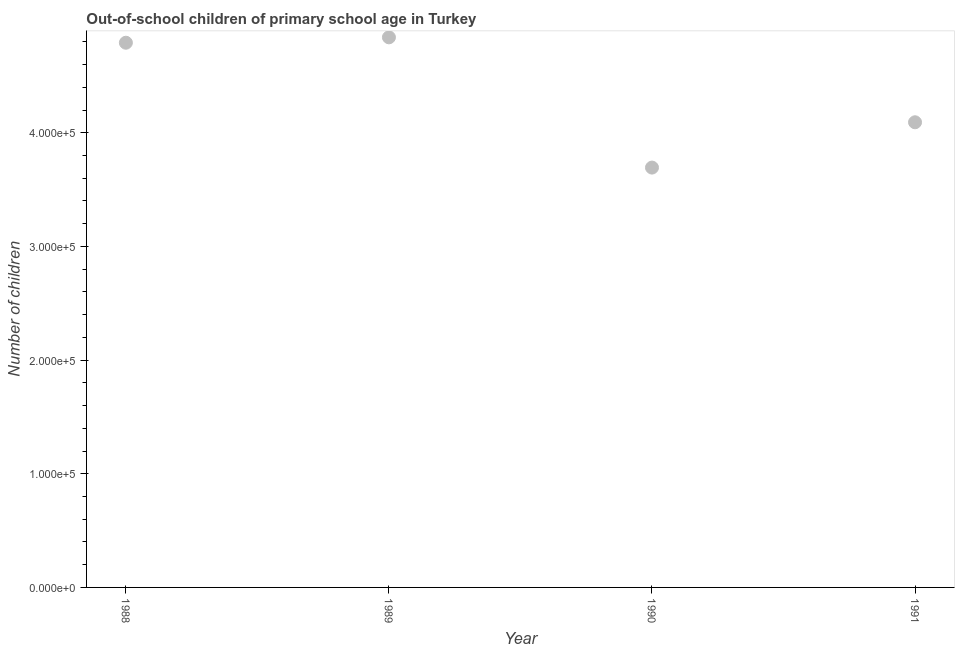What is the number of out-of-school children in 1989?
Offer a terse response. 4.84e+05. Across all years, what is the maximum number of out-of-school children?
Give a very brief answer. 4.84e+05. Across all years, what is the minimum number of out-of-school children?
Your answer should be very brief. 3.69e+05. In which year was the number of out-of-school children minimum?
Offer a terse response. 1990. What is the sum of the number of out-of-school children?
Make the answer very short. 1.74e+06. What is the difference between the number of out-of-school children in 1989 and 1991?
Offer a very short reply. 7.47e+04. What is the average number of out-of-school children per year?
Ensure brevity in your answer.  4.35e+05. What is the median number of out-of-school children?
Provide a short and direct response. 4.44e+05. In how many years, is the number of out-of-school children greater than 460000 ?
Offer a terse response. 2. What is the ratio of the number of out-of-school children in 1989 to that in 1991?
Offer a terse response. 1.18. Is the number of out-of-school children in 1988 less than that in 1989?
Your answer should be very brief. Yes. Is the difference between the number of out-of-school children in 1990 and 1991 greater than the difference between any two years?
Provide a short and direct response. No. What is the difference between the highest and the second highest number of out-of-school children?
Offer a very short reply. 4741. What is the difference between the highest and the lowest number of out-of-school children?
Make the answer very short. 1.15e+05. Does the number of out-of-school children monotonically increase over the years?
Ensure brevity in your answer.  No. How many years are there in the graph?
Your answer should be very brief. 4. Does the graph contain grids?
Ensure brevity in your answer.  No. What is the title of the graph?
Provide a succinct answer. Out-of-school children of primary school age in Turkey. What is the label or title of the X-axis?
Give a very brief answer. Year. What is the label or title of the Y-axis?
Your response must be concise. Number of children. What is the Number of children in 1988?
Your answer should be very brief. 4.79e+05. What is the Number of children in 1989?
Your response must be concise. 4.84e+05. What is the Number of children in 1990?
Give a very brief answer. 3.69e+05. What is the Number of children in 1991?
Keep it short and to the point. 4.09e+05. What is the difference between the Number of children in 1988 and 1989?
Provide a succinct answer. -4741. What is the difference between the Number of children in 1988 and 1990?
Keep it short and to the point. 1.10e+05. What is the difference between the Number of children in 1988 and 1991?
Your answer should be compact. 7.00e+04. What is the difference between the Number of children in 1989 and 1990?
Your answer should be very brief. 1.15e+05. What is the difference between the Number of children in 1989 and 1991?
Offer a very short reply. 7.47e+04. What is the difference between the Number of children in 1990 and 1991?
Provide a succinct answer. -3.99e+04. What is the ratio of the Number of children in 1988 to that in 1989?
Provide a short and direct response. 0.99. What is the ratio of the Number of children in 1988 to that in 1990?
Your response must be concise. 1.3. What is the ratio of the Number of children in 1988 to that in 1991?
Keep it short and to the point. 1.17. What is the ratio of the Number of children in 1989 to that in 1990?
Provide a short and direct response. 1.31. What is the ratio of the Number of children in 1989 to that in 1991?
Keep it short and to the point. 1.18. What is the ratio of the Number of children in 1990 to that in 1991?
Provide a short and direct response. 0.9. 